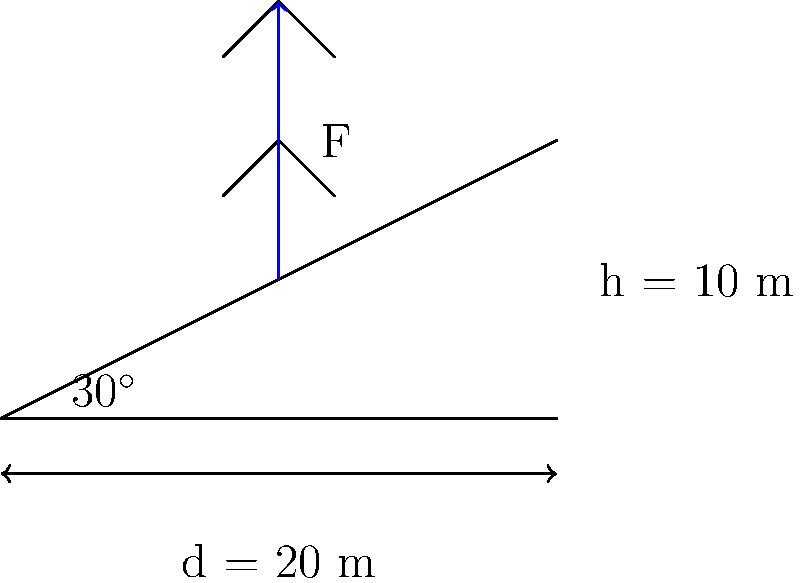As a health-conscious professional trying to maintain an active lifestyle, you decide to incorporate incline treadmill walks into your routine. If you walk up a treadmill inclined at 30° to the horizontal for a distance of 20 m, and the vertical height gained is 10 m, calculate the work done against gravity if your mass is 70 kg. Assume g = 9.8 m/s². To calculate the work done against gravity, we'll follow these steps:

1) The work done against gravity is given by the formula:
   $$W = mgh$$
   where:
   $W$ = work done
   $m$ = mass of the person
   $g$ = acceleration due to gravity
   $h$ = vertical height gained

2) We're given:
   $m = 70$ kg
   $g = 9.8$ m/s²
   $h = 10$ m

3) Substituting these values into the formula:
   $$W = 70 \text{ kg} \times 9.8 \text{ m/s²} \times 10 \text{ m}$$

4) Calculate:
   $$W = 6860 \text{ J}$$

5) The work done is 6860 Joules.

Note: The angle of inclination and the distance walked along the treadmill are not directly used in this calculation. What matters is the vertical height gained against gravity.
Answer: 6860 J 